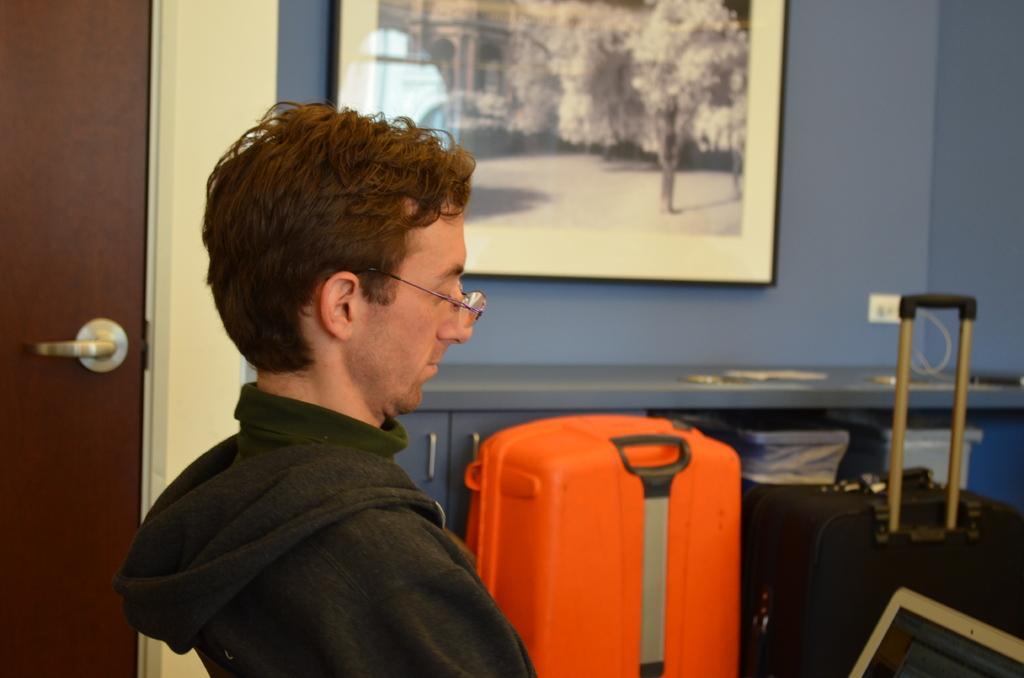How would you summarize this image in a sentence or two? this picture shows a man seated and he wore a spectacles on his face and we see a trolley bag and we see a photo frame on the wall 